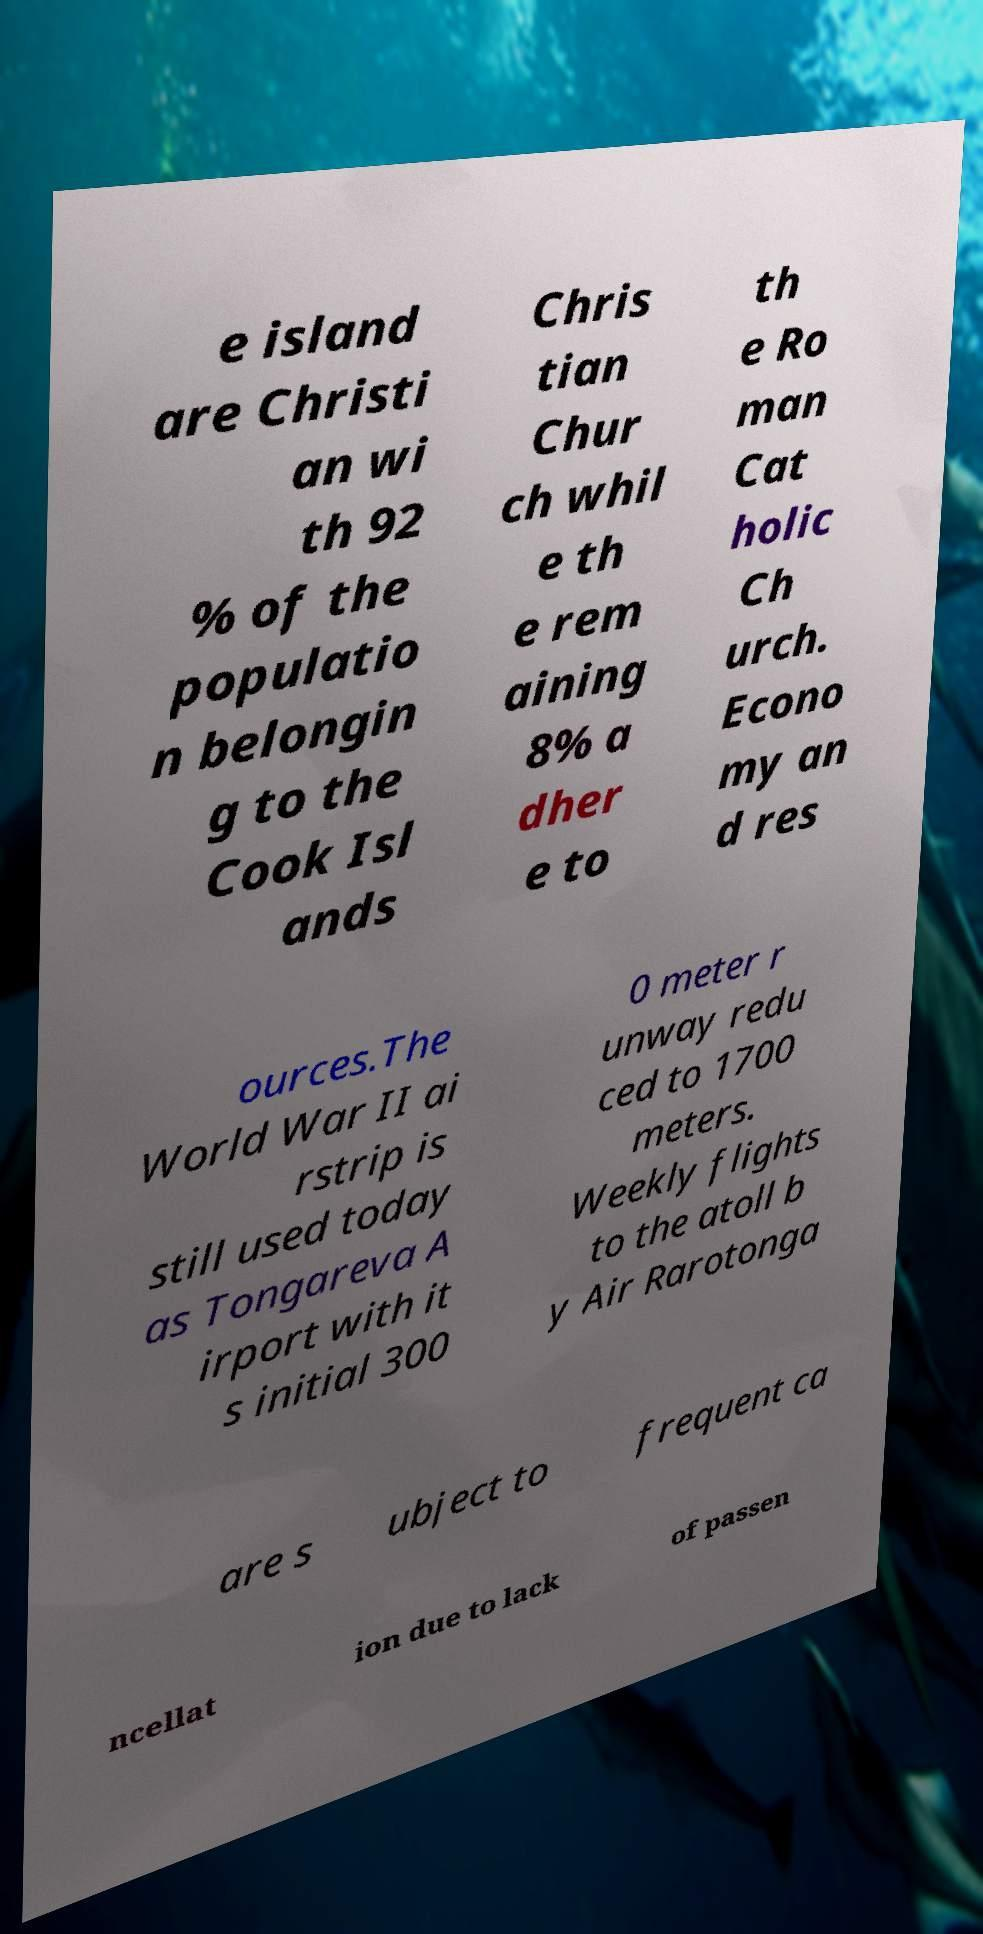Please read and relay the text visible in this image. What does it say? e island are Christi an wi th 92 % of the populatio n belongin g to the Cook Isl ands Chris tian Chur ch whil e th e rem aining 8% a dher e to th e Ro man Cat holic Ch urch. Econo my an d res ources.The World War II ai rstrip is still used today as Tongareva A irport with it s initial 300 0 meter r unway redu ced to 1700 meters. Weekly flights to the atoll b y Air Rarotonga are s ubject to frequent ca ncellat ion due to lack of passen 